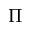<formula> <loc_0><loc_0><loc_500><loc_500>\Pi</formula> 